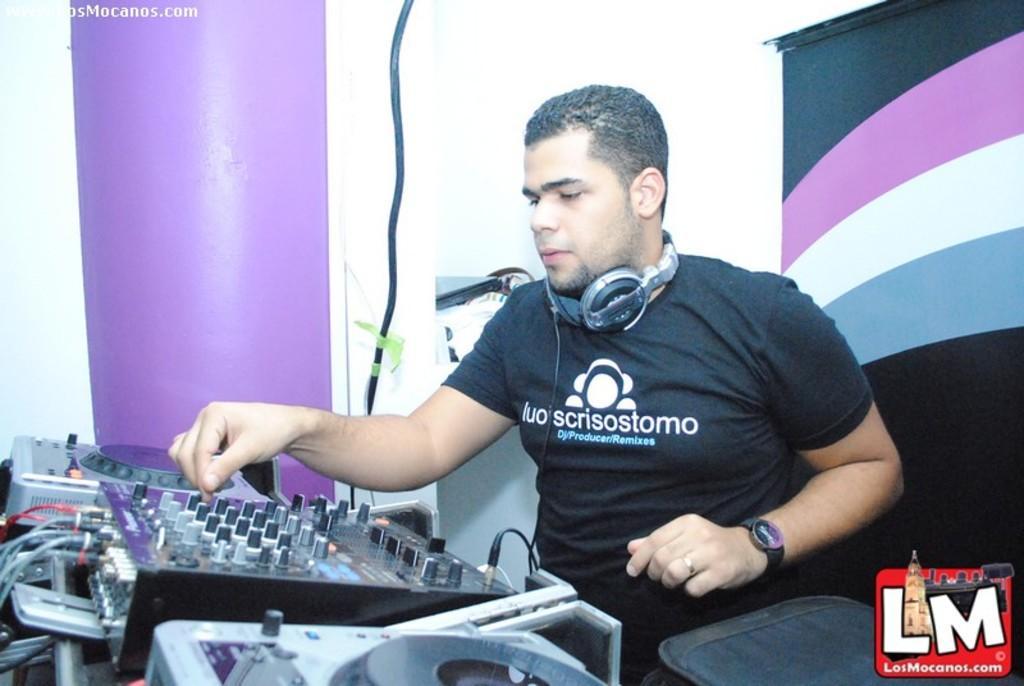Describe this image in one or two sentences. This is the man sitting. These are the kind of electronic devices with wires attached to it. This man wore a headset around his neck. This looks like a bag. I can see the watermarks on the image. 